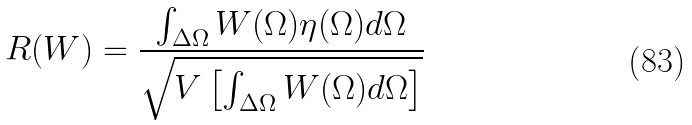<formula> <loc_0><loc_0><loc_500><loc_500>R ( W ) = \frac { \int _ { \Delta \Omega } W ( \Omega ) \eta ( \Omega ) d \Omega } { \sqrt { V \left [ \int _ { \Delta \Omega } W ( \Omega ) d \Omega \right ] } }</formula> 